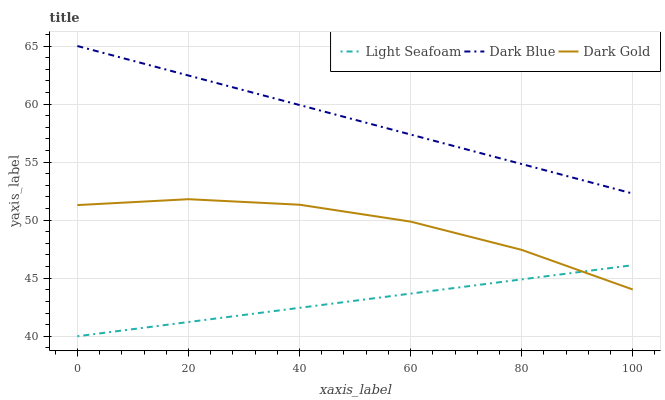Does Dark Gold have the minimum area under the curve?
Answer yes or no. No. Does Dark Gold have the maximum area under the curve?
Answer yes or no. No. Is Dark Gold the smoothest?
Answer yes or no. No. Is Light Seafoam the roughest?
Answer yes or no. No. Does Dark Gold have the lowest value?
Answer yes or no. No. Does Dark Gold have the highest value?
Answer yes or no. No. Is Dark Gold less than Dark Blue?
Answer yes or no. Yes. Is Dark Blue greater than Dark Gold?
Answer yes or no. Yes. Does Dark Gold intersect Dark Blue?
Answer yes or no. No. 